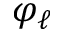<formula> <loc_0><loc_0><loc_500><loc_500>\varphi _ { \ell }</formula> 